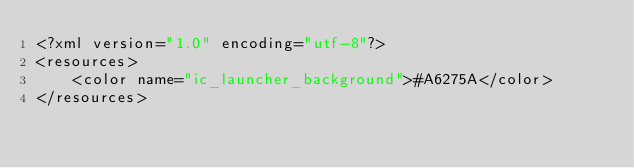Convert code to text. <code><loc_0><loc_0><loc_500><loc_500><_XML_><?xml version="1.0" encoding="utf-8"?>
<resources>
    <color name="ic_launcher_background">#A6275A</color>
</resources></code> 